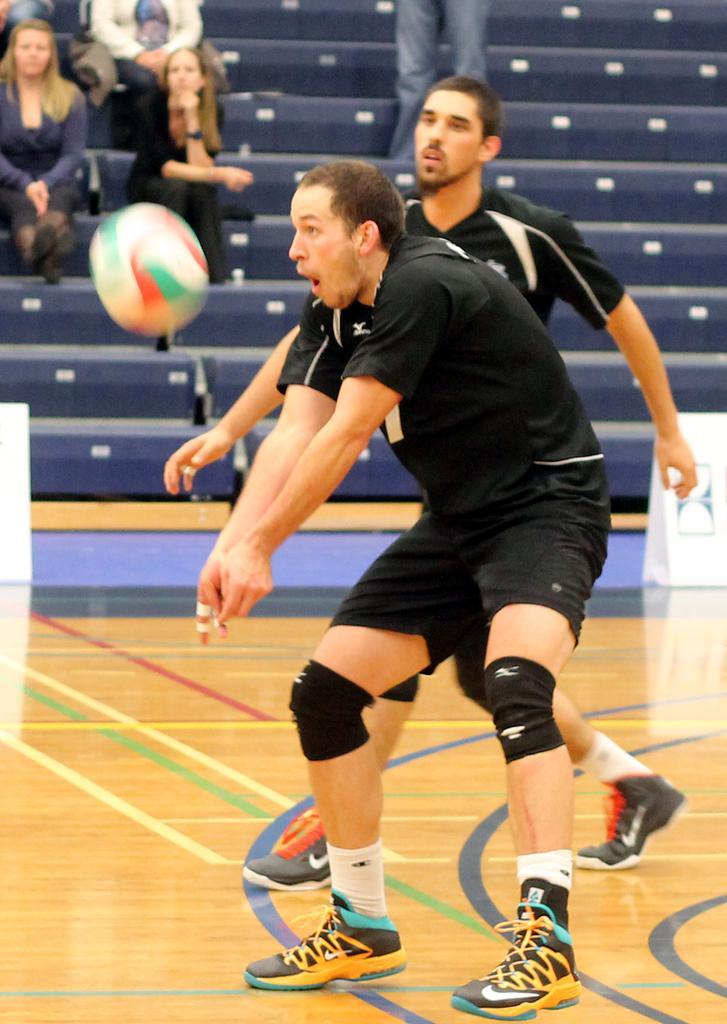Describe this image in one or two sentences. In this image I can see two persons playing game and they are wearing black color dresses. Background I can see few persons sitting and I can also see few stairs. In front I can see the ball in white, red and green color. 